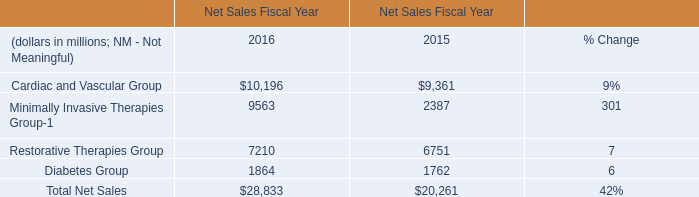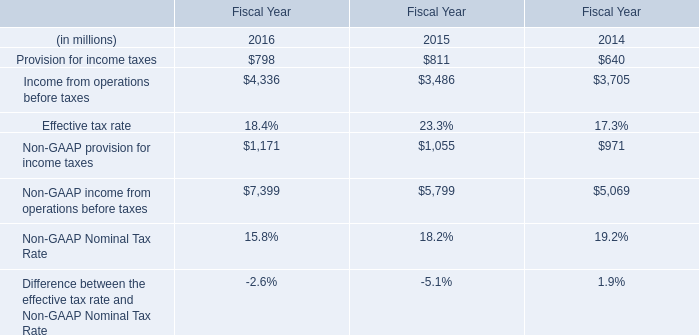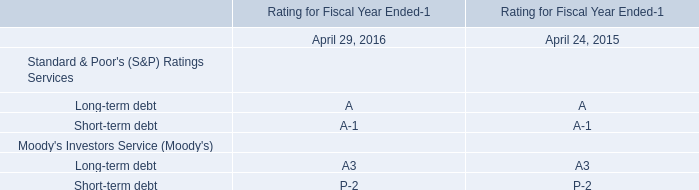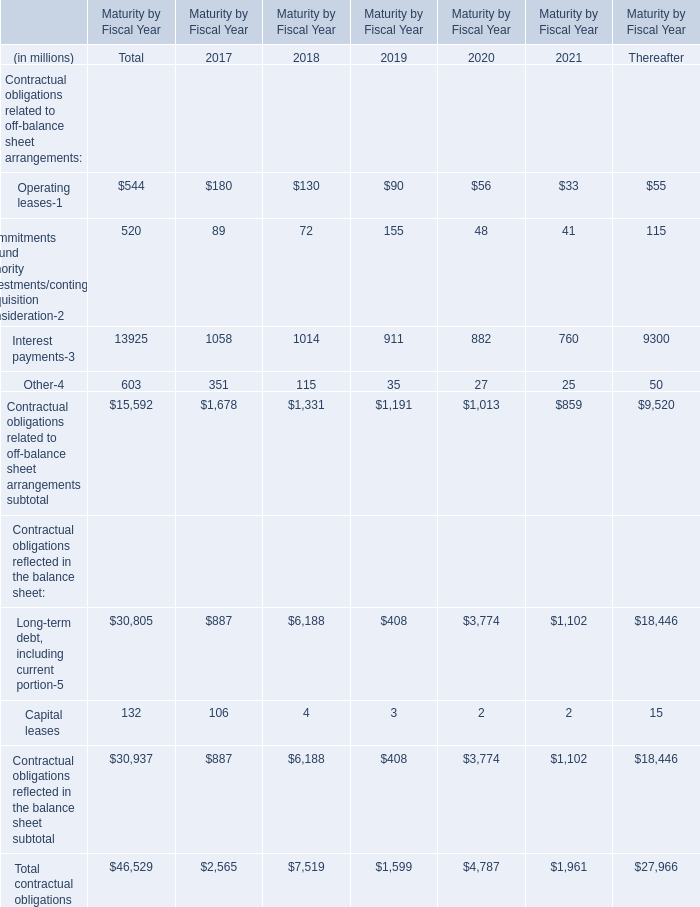Which year is Long-term debt, including current portion the most? 
Answer: 2018. 